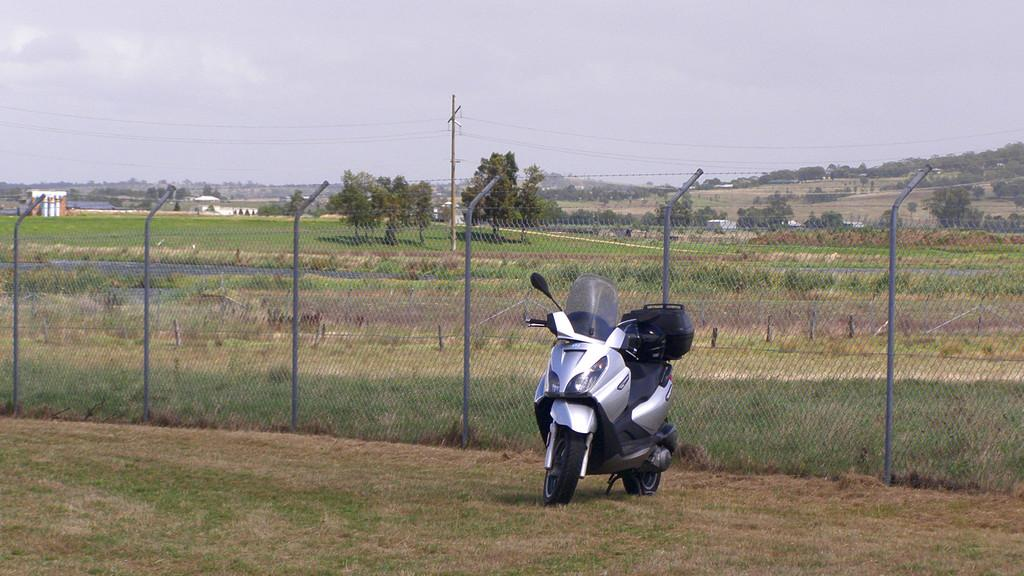What is on the scooter in the image? There is a box on the scooter. What can be seen in the background of the image? There is mesh fencing with poles, trees, buildings, and the sky visible in the background. What is the purpose of the electric pole in the image? The electric pole has wires attached to it. How many boats are visible in the image? There are no boats present in the image. Can you describe the haircut of the person riding the scooter? There is no person riding the scooter in the image, so it is not possible to describe their haircut. 